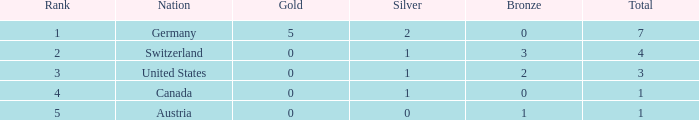What is the total number of bronze when the total is less than 1? None. 